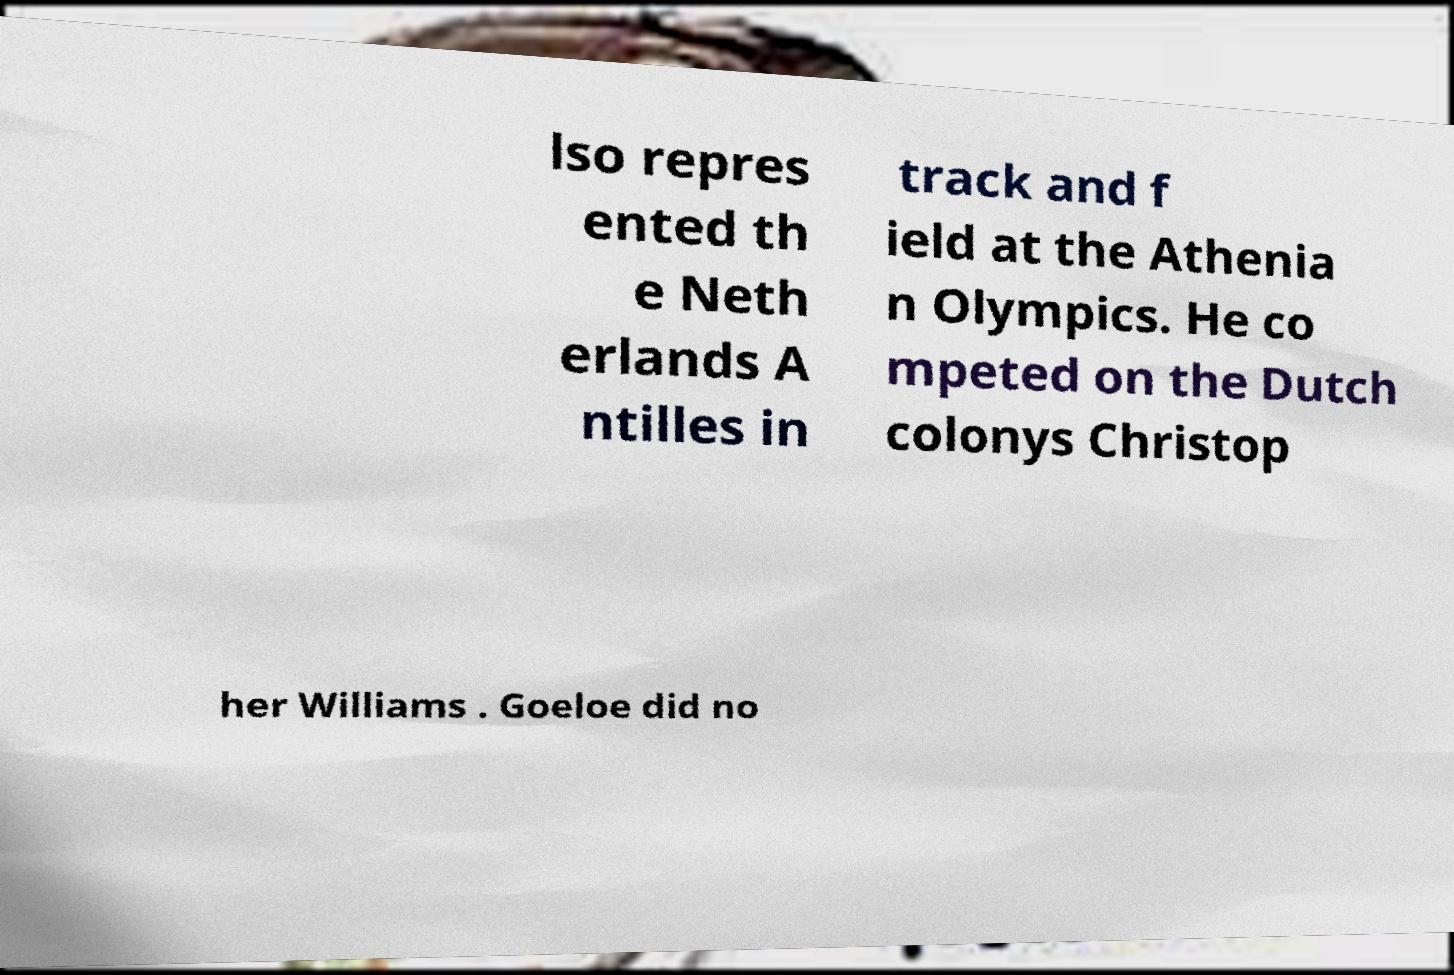Could you extract and type out the text from this image? lso repres ented th e Neth erlands A ntilles in track and f ield at the Athenia n Olympics. He co mpeted on the Dutch colonys Christop her Williams . Goeloe did no 